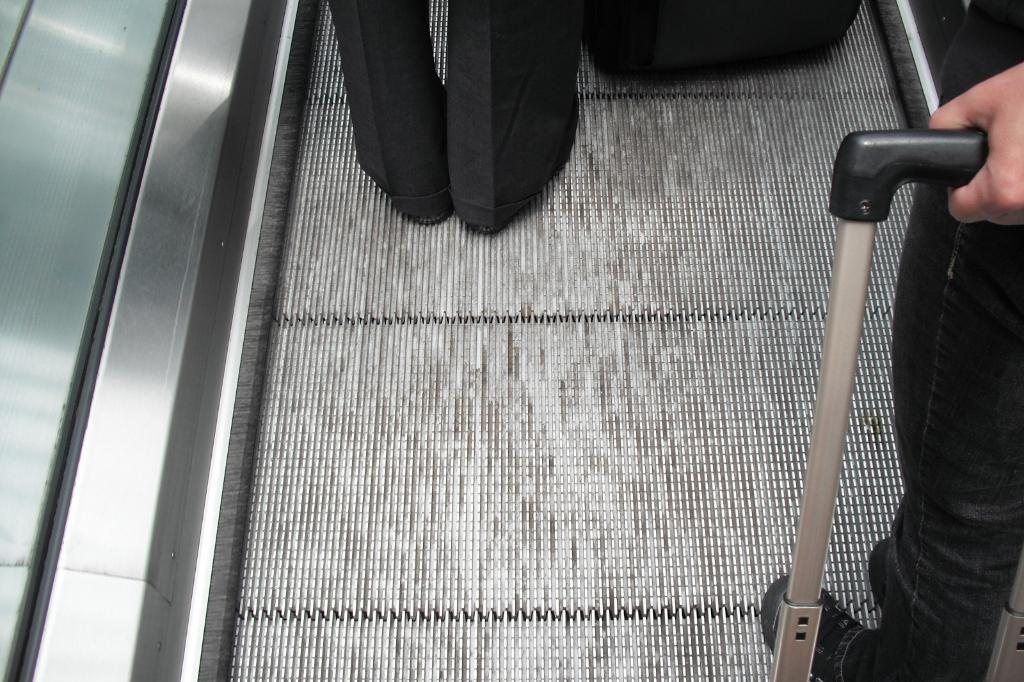What type of transportation or movement device is present in the image? There is an escalator in the image. Can you describe the person in the image? A person is standing on the escalator. What time of day is it in the image, based on the position of the scarecrow? There is no scarecrow present in the image, so we cannot determine the time of day based on its position. 